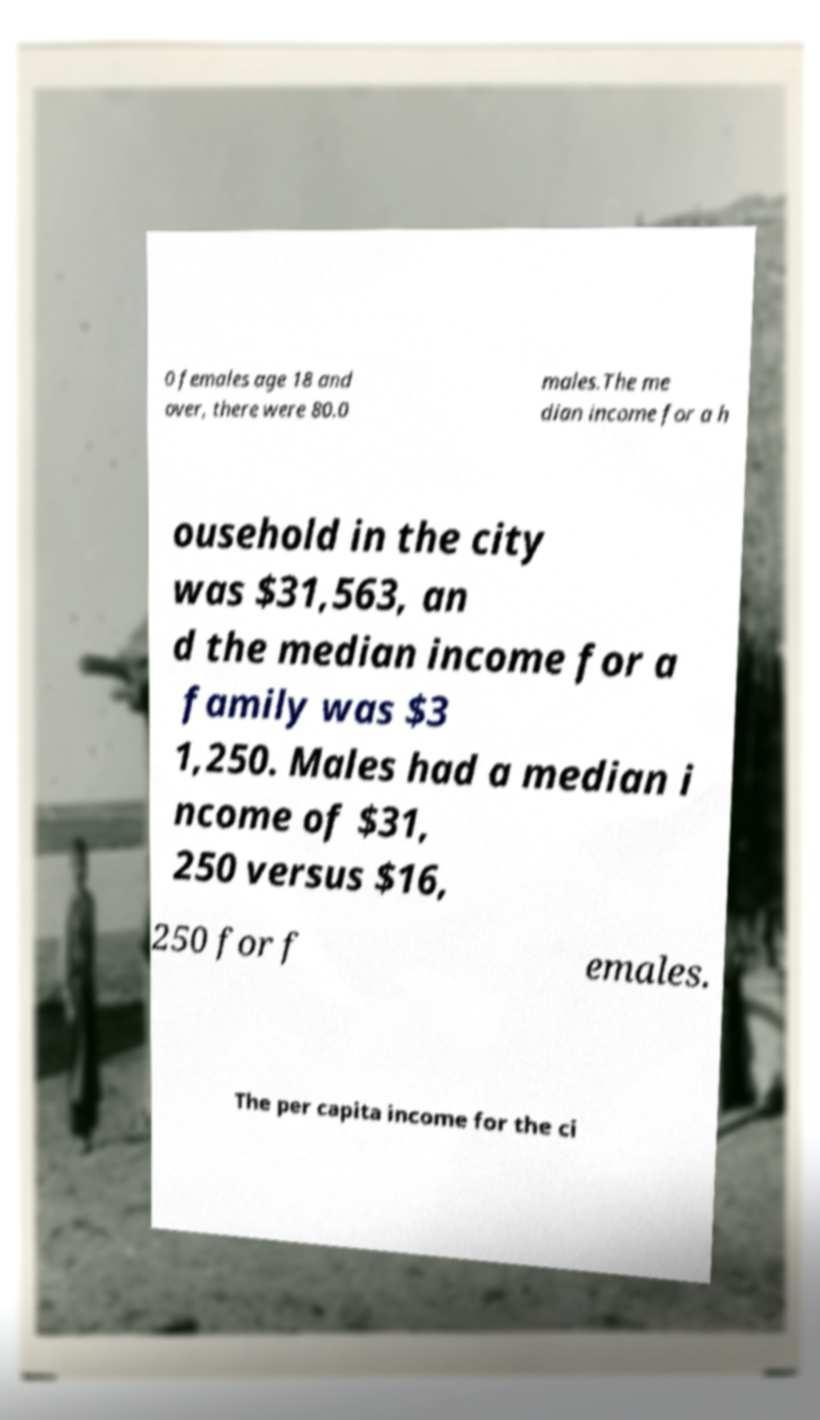Can you accurately transcribe the text from the provided image for me? 0 females age 18 and over, there were 80.0 males.The me dian income for a h ousehold in the city was $31,563, an d the median income for a family was $3 1,250. Males had a median i ncome of $31, 250 versus $16, 250 for f emales. The per capita income for the ci 